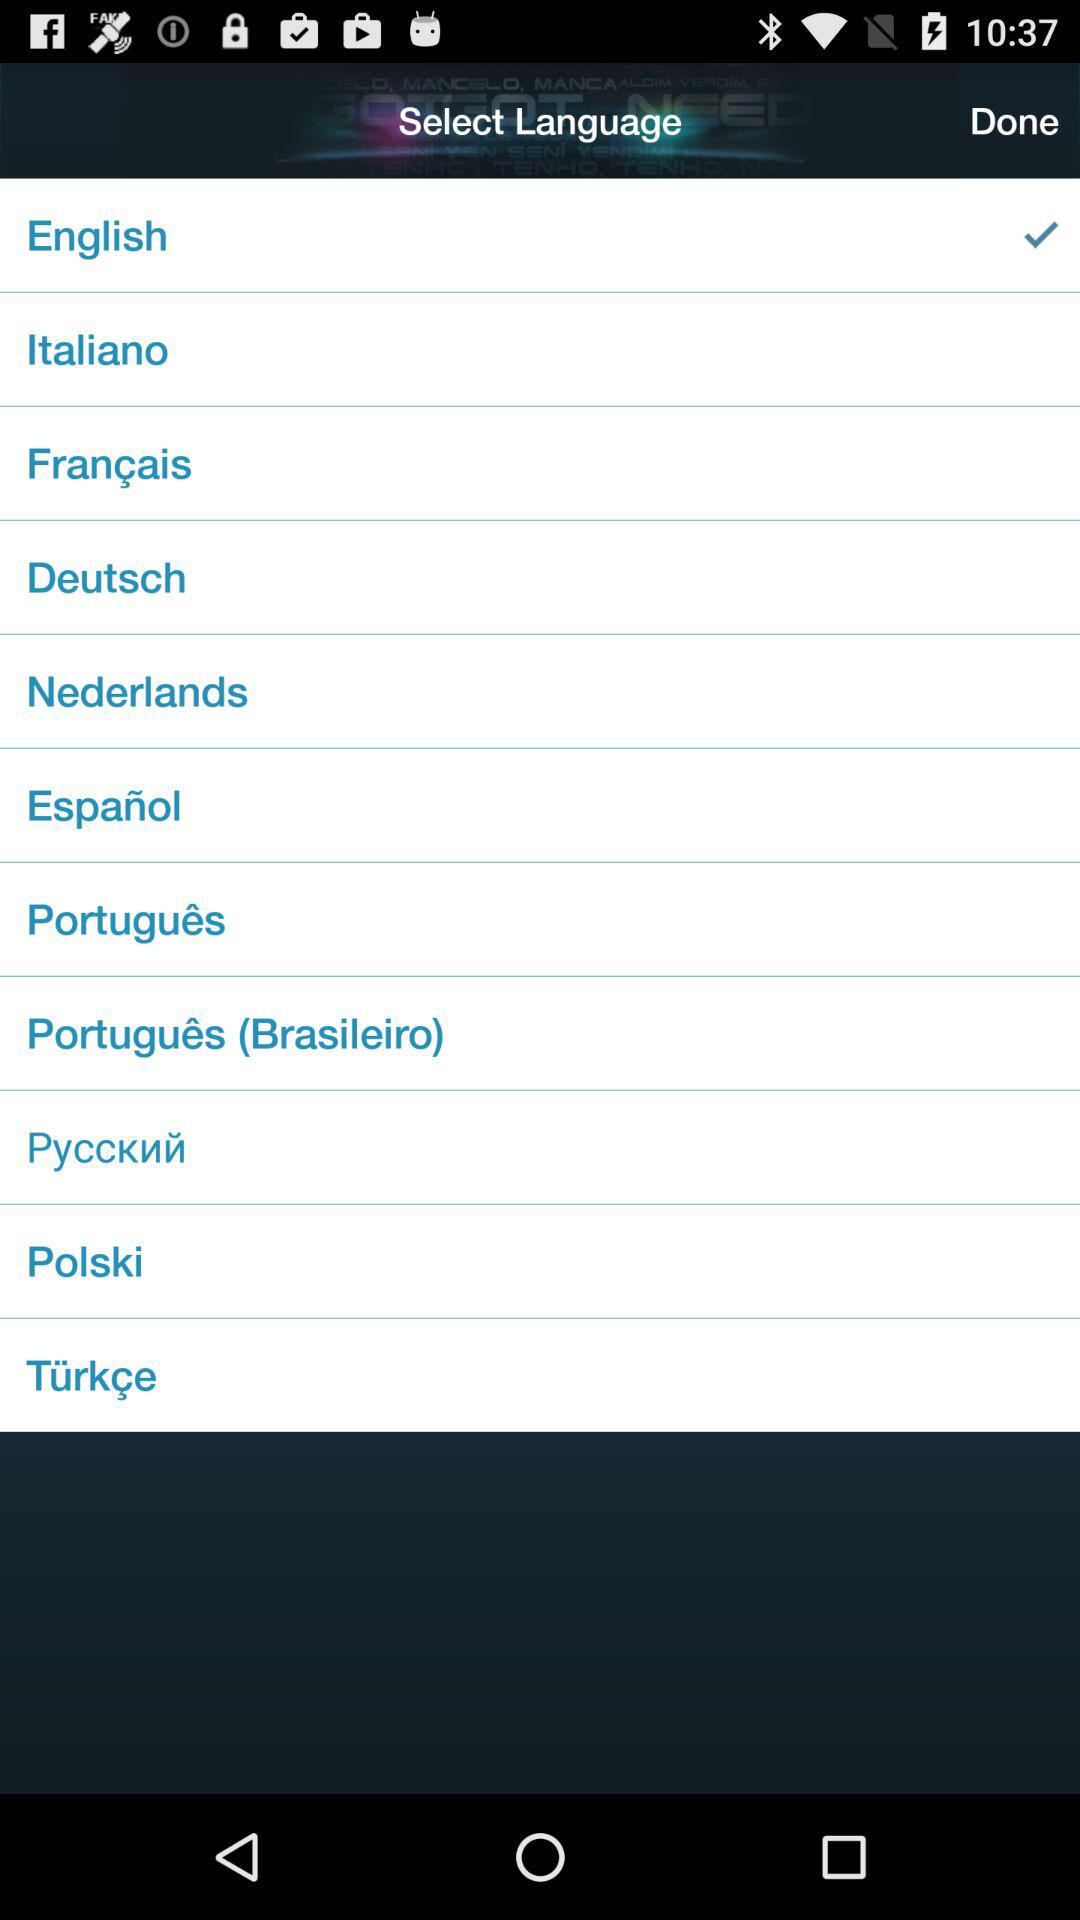Which is the selected language? The selected language is English. 